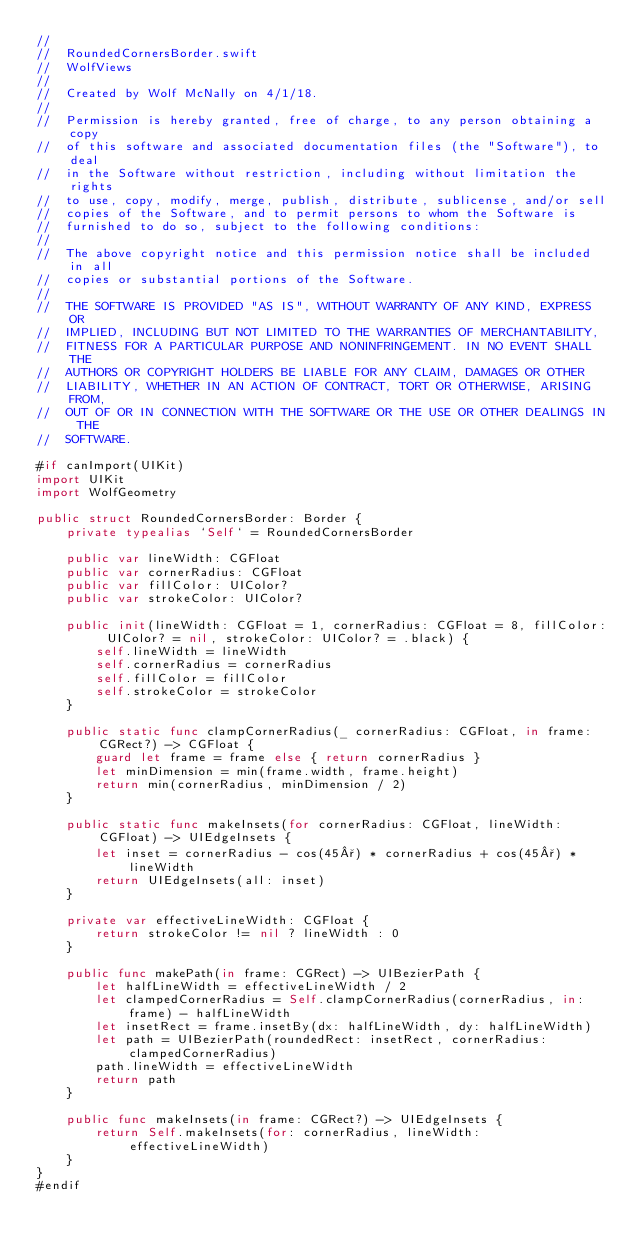Convert code to text. <code><loc_0><loc_0><loc_500><loc_500><_Swift_>//
//  RoundedCornersBorder.swift
//  WolfViews
//
//  Created by Wolf McNally on 4/1/18.
//
//  Permission is hereby granted, free of charge, to any person obtaining a copy
//  of this software and associated documentation files (the "Software"), to deal
//  in the Software without restriction, including without limitation the rights
//  to use, copy, modify, merge, publish, distribute, sublicense, and/or sell
//  copies of the Software, and to permit persons to whom the Software is
//  furnished to do so, subject to the following conditions:
//
//  The above copyright notice and this permission notice shall be included in all
//  copies or substantial portions of the Software.
//
//  THE SOFTWARE IS PROVIDED "AS IS", WITHOUT WARRANTY OF ANY KIND, EXPRESS OR
//  IMPLIED, INCLUDING BUT NOT LIMITED TO THE WARRANTIES OF MERCHANTABILITY,
//  FITNESS FOR A PARTICULAR PURPOSE AND NONINFRINGEMENT. IN NO EVENT SHALL THE
//  AUTHORS OR COPYRIGHT HOLDERS BE LIABLE FOR ANY CLAIM, DAMAGES OR OTHER
//  LIABILITY, WHETHER IN AN ACTION OF CONTRACT, TORT OR OTHERWISE, ARISING FROM,
//  OUT OF OR IN CONNECTION WITH THE SOFTWARE OR THE USE OR OTHER DEALINGS IN THE
//  SOFTWARE.

#if canImport(UIKit)
import UIKit
import WolfGeometry

public struct RoundedCornersBorder: Border {
    private typealias `Self` = RoundedCornersBorder

    public var lineWidth: CGFloat
    public var cornerRadius: CGFloat
    public var fillColor: UIColor?
    public var strokeColor: UIColor?

    public init(lineWidth: CGFloat = 1, cornerRadius: CGFloat = 8, fillColor: UIColor? = nil, strokeColor: UIColor? = .black) {
        self.lineWidth = lineWidth
        self.cornerRadius = cornerRadius
        self.fillColor = fillColor
        self.strokeColor = strokeColor
    }

    public static func clampCornerRadius(_ cornerRadius: CGFloat, in frame: CGRect?) -> CGFloat {
        guard let frame = frame else { return cornerRadius }
        let minDimension = min(frame.width, frame.height)
        return min(cornerRadius, minDimension / 2)
    }

    public static func makeInsets(for cornerRadius: CGFloat, lineWidth: CGFloat) -> UIEdgeInsets {
        let inset = cornerRadius - cos(45°) * cornerRadius + cos(45°) * lineWidth
        return UIEdgeInsets(all: inset)
    }

    private var effectiveLineWidth: CGFloat {
        return strokeColor != nil ? lineWidth : 0
    }

    public func makePath(in frame: CGRect) -> UIBezierPath {
        let halfLineWidth = effectiveLineWidth / 2
        let clampedCornerRadius = Self.clampCornerRadius(cornerRadius, in: frame) - halfLineWidth
        let insetRect = frame.insetBy(dx: halfLineWidth, dy: halfLineWidth)
        let path = UIBezierPath(roundedRect: insetRect, cornerRadius: clampedCornerRadius)
        path.lineWidth = effectiveLineWidth
        return path
    }

    public func makeInsets(in frame: CGRect?) -> UIEdgeInsets {
        return Self.makeInsets(for: cornerRadius, lineWidth: effectiveLineWidth)
    }
}
#endif
</code> 